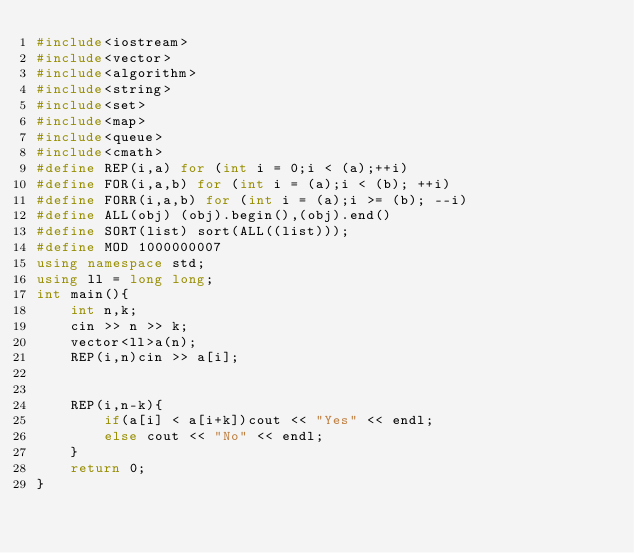Convert code to text. <code><loc_0><loc_0><loc_500><loc_500><_C++_>#include<iostream>
#include<vector>
#include<algorithm>
#include<string>
#include<set>
#include<map>
#include<queue>
#include<cmath>
#define REP(i,a) for (int i = 0;i < (a);++i)
#define FOR(i,a,b) for (int i = (a);i < (b); ++i)
#define FORR(i,a,b) for (int i = (a);i >= (b); --i)
#define ALL(obj) (obj).begin(),(obj).end()
#define SORT(list) sort(ALL((list)));
#define MOD 1000000007
using namespace std;
using ll = long long;
int main(){
    int n,k;
    cin >> n >> k;
    vector<ll>a(n);
    REP(i,n)cin >> a[i];
    
    
    REP(i,n-k){
        if(a[i] < a[i+k])cout << "Yes" << endl;
        else cout << "No" << endl;
    }
    return 0;
}</code> 